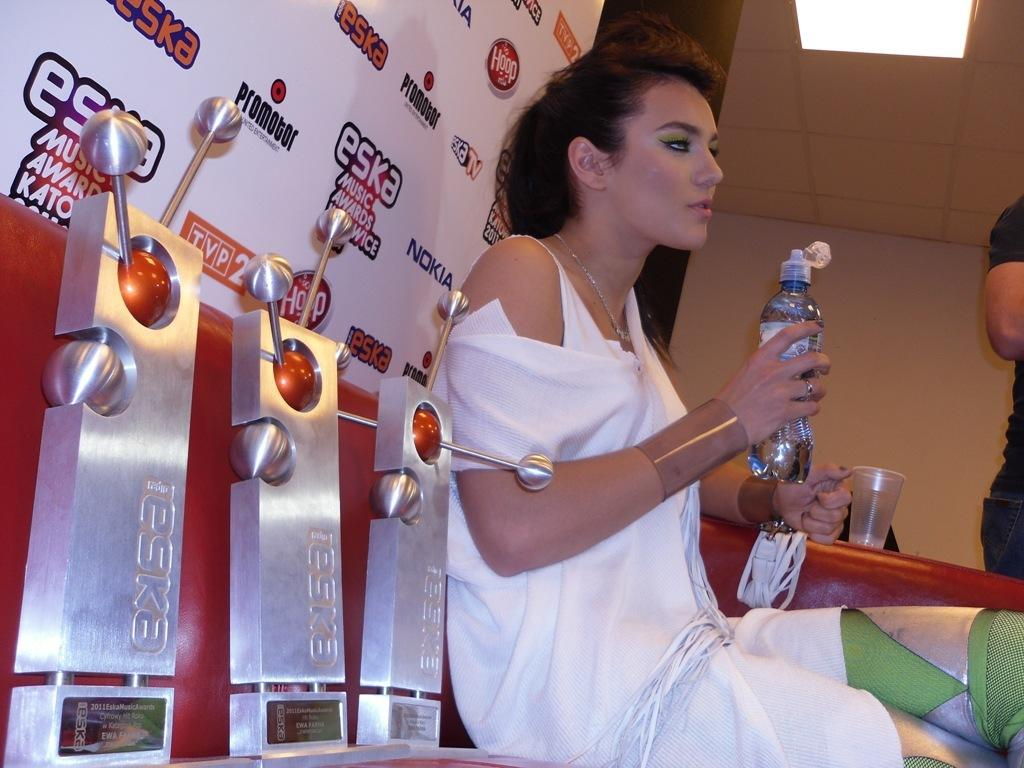Who is the main subject in the image? There is a woman in the image. What is the woman doing in the image? The woman is sitting on a sofa. What object is the woman holding in her right hand? The woman is holding a glass bottle in her right hand. What type of government is depicted in the image? There is no depiction of a government in the image; it features a woman sitting on a sofa and holding a glass bottle. 